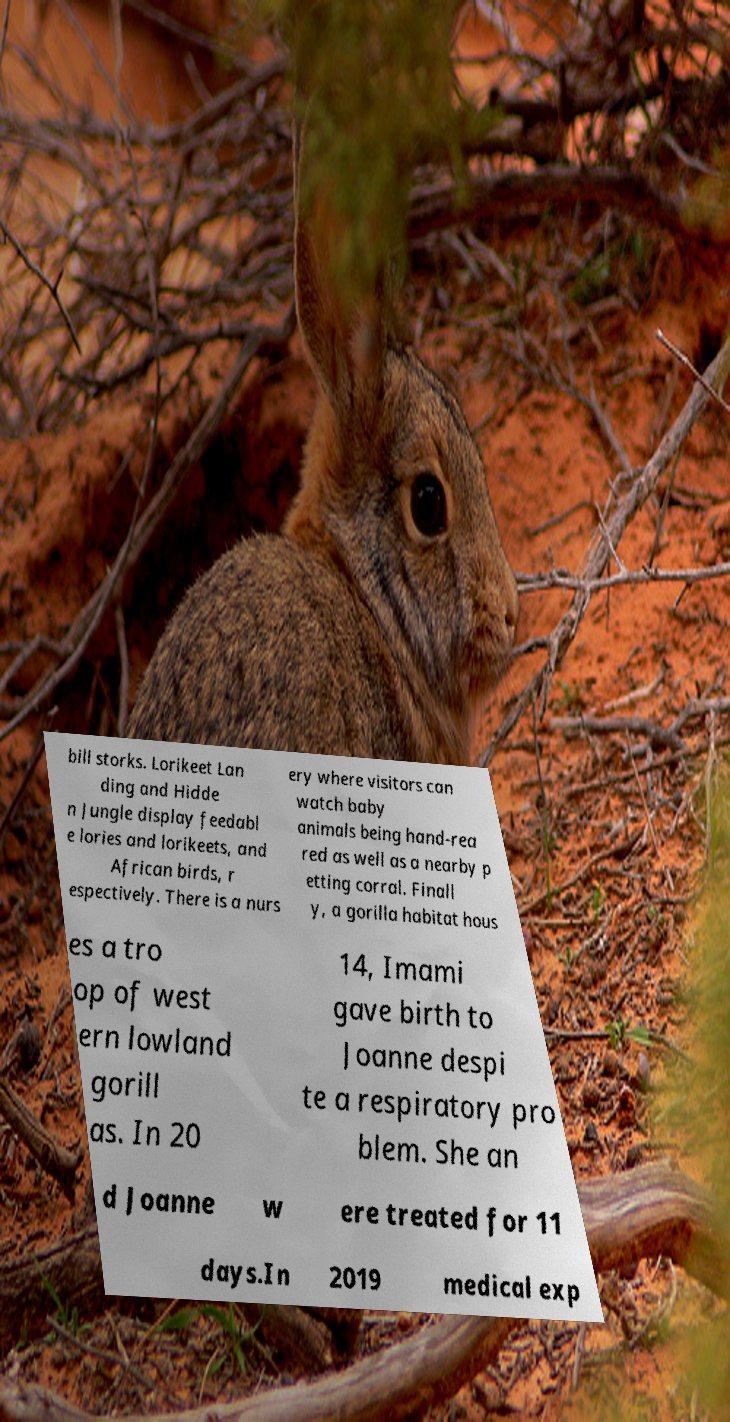Could you assist in decoding the text presented in this image and type it out clearly? bill storks. Lorikeet Lan ding and Hidde n Jungle display feedabl e lories and lorikeets, and African birds, r espectively. There is a nurs ery where visitors can watch baby animals being hand-rea red as well as a nearby p etting corral. Finall y, a gorilla habitat hous es a tro op of west ern lowland gorill as. In 20 14, Imami gave birth to Joanne despi te a respiratory pro blem. She an d Joanne w ere treated for 11 days.In 2019 medical exp 